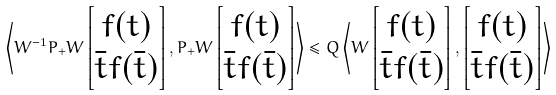<formula> <loc_0><loc_0><loc_500><loc_500>\left \langle W ^ { - 1 } P _ { + } W \begin{bmatrix} f ( t ) \\ \bar { t } f ( \bar { t } ) \end{bmatrix} , P _ { + } W \begin{bmatrix} f ( t ) \\ \bar { t } f ( \bar { t } ) \end{bmatrix} \right \rangle \leq Q \left \langle W \begin{bmatrix} f ( t ) \\ \bar { t } f ( \bar { t } ) \end{bmatrix} , \begin{bmatrix} f ( t ) \\ \bar { t } f ( \bar { t } ) \end{bmatrix} \right \rangle</formula> 